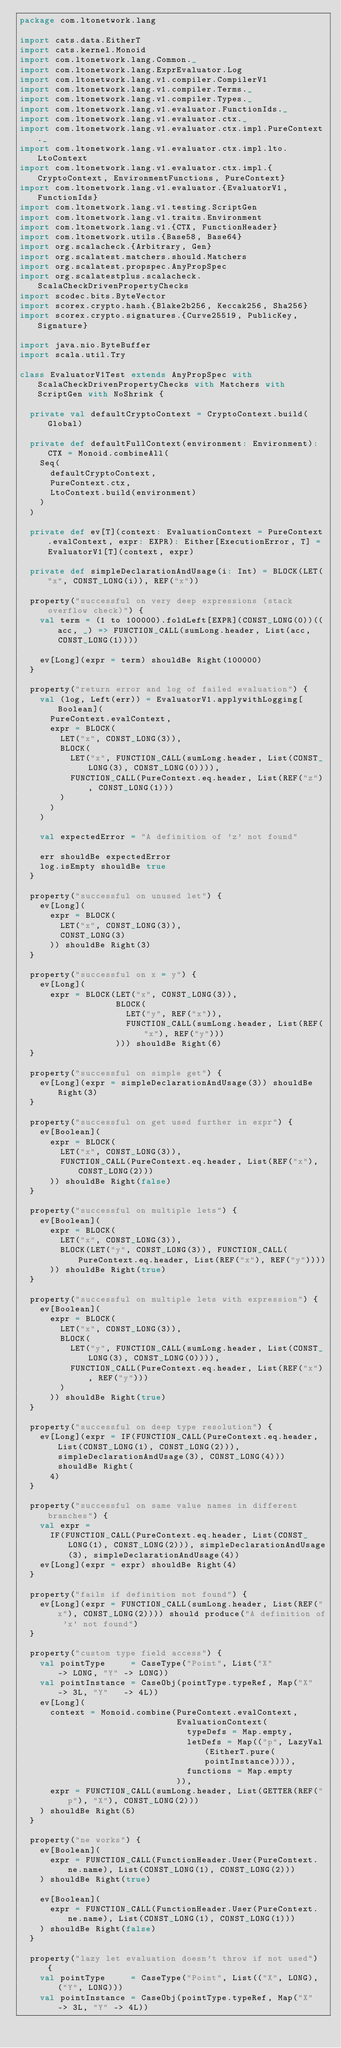<code> <loc_0><loc_0><loc_500><loc_500><_Scala_>package com.ltonetwork.lang

import cats.data.EitherT
import cats.kernel.Monoid
import com.ltonetwork.lang.Common._
import com.ltonetwork.lang.ExprEvaluator.Log
import com.ltonetwork.lang.v1.compiler.CompilerV1
import com.ltonetwork.lang.v1.compiler.Terms._
import com.ltonetwork.lang.v1.compiler.Types._
import com.ltonetwork.lang.v1.evaluator.FunctionIds._
import com.ltonetwork.lang.v1.evaluator.ctx._
import com.ltonetwork.lang.v1.evaluator.ctx.impl.PureContext._
import com.ltonetwork.lang.v1.evaluator.ctx.impl.lto.LtoContext
import com.ltonetwork.lang.v1.evaluator.ctx.impl.{CryptoContext, EnvironmentFunctions, PureContext}
import com.ltonetwork.lang.v1.evaluator.{EvaluatorV1, FunctionIds}
import com.ltonetwork.lang.v1.testing.ScriptGen
import com.ltonetwork.lang.v1.traits.Environment
import com.ltonetwork.lang.v1.{CTX, FunctionHeader}
import com.ltonetwork.utils.{Base58, Base64}
import org.scalacheck.{Arbitrary, Gen}
import org.scalatest.matchers.should.Matchers
import org.scalatest.propspec.AnyPropSpec
import org.scalatestplus.scalacheck.ScalaCheckDrivenPropertyChecks
import scodec.bits.ByteVector
import scorex.crypto.hash.{Blake2b256, Keccak256, Sha256}
import scorex.crypto.signatures.{Curve25519, PublicKey, Signature}

import java.nio.ByteBuffer
import scala.util.Try

class EvaluatorV1Test extends AnyPropSpec with ScalaCheckDrivenPropertyChecks with Matchers with ScriptGen with NoShrink {

  private val defaultCryptoContext = CryptoContext.build(Global)

  private def defaultFullContext(environment: Environment): CTX = Monoid.combineAll(
    Seq(
      defaultCryptoContext,
      PureContext.ctx,
      LtoContext.build(environment)
    )
  )

  private def ev[T](context: EvaluationContext = PureContext.evalContext, expr: EXPR): Either[ExecutionError, T] = EvaluatorV1[T](context, expr)

  private def simpleDeclarationAndUsage(i: Int) = BLOCK(LET("x", CONST_LONG(i)), REF("x"))

  property("successful on very deep expressions (stack overflow check)") {
    val term = (1 to 100000).foldLeft[EXPR](CONST_LONG(0))((acc, _) => FUNCTION_CALL(sumLong.header, List(acc, CONST_LONG(1))))

    ev[Long](expr = term) shouldBe Right(100000)
  }

  property("return error and log of failed evaluation") {
    val (log, Left(err)) = EvaluatorV1.applywithLogging[Boolean](
      PureContext.evalContext,
      expr = BLOCK(
        LET("x", CONST_LONG(3)),
        BLOCK(
          LET("x", FUNCTION_CALL(sumLong.header, List(CONST_LONG(3), CONST_LONG(0)))),
          FUNCTION_CALL(PureContext.eq.header, List(REF("z"), CONST_LONG(1)))
        )
      )
    )

    val expectedError = "A definition of 'z' not found"

    err shouldBe expectedError
    log.isEmpty shouldBe true
  }

  property("successful on unused let") {
    ev[Long](
      expr = BLOCK(
        LET("x", CONST_LONG(3)),
        CONST_LONG(3)
      )) shouldBe Right(3)
  }

  property("successful on x = y") {
    ev[Long](
      expr = BLOCK(LET("x", CONST_LONG(3)),
                   BLOCK(
                     LET("y", REF("x")),
                     FUNCTION_CALL(sumLong.header, List(REF("x"), REF("y")))
                   ))) shouldBe Right(6)
  }

  property("successful on simple get") {
    ev[Long](expr = simpleDeclarationAndUsage(3)) shouldBe Right(3)
  }

  property("successful on get used further in expr") {
    ev[Boolean](
      expr = BLOCK(
        LET("x", CONST_LONG(3)),
        FUNCTION_CALL(PureContext.eq.header, List(REF("x"), CONST_LONG(2)))
      )) shouldBe Right(false)
  }

  property("successful on multiple lets") {
    ev[Boolean](
      expr = BLOCK(
        LET("x", CONST_LONG(3)),
        BLOCK(LET("y", CONST_LONG(3)), FUNCTION_CALL(PureContext.eq.header, List(REF("x"), REF("y"))))
      )) shouldBe Right(true)
  }

  property("successful on multiple lets with expression") {
    ev[Boolean](
      expr = BLOCK(
        LET("x", CONST_LONG(3)),
        BLOCK(
          LET("y", FUNCTION_CALL(sumLong.header, List(CONST_LONG(3), CONST_LONG(0)))),
          FUNCTION_CALL(PureContext.eq.header, List(REF("x"), REF("y")))
        )
      )) shouldBe Right(true)
  }

  property("successful on deep type resolution") {
    ev[Long](expr = IF(FUNCTION_CALL(PureContext.eq.header, List(CONST_LONG(1), CONST_LONG(2))), simpleDeclarationAndUsage(3), CONST_LONG(4))) shouldBe Right(
      4)
  }

  property("successful on same value names in different branches") {
    val expr =
      IF(FUNCTION_CALL(PureContext.eq.header, List(CONST_LONG(1), CONST_LONG(2))), simpleDeclarationAndUsage(3), simpleDeclarationAndUsage(4))
    ev[Long](expr = expr) shouldBe Right(4)
  }

  property("fails if definition not found") {
    ev[Long](expr = FUNCTION_CALL(sumLong.header, List(REF("x"), CONST_LONG(2)))) should produce("A definition of 'x' not found")
  }

  property("custom type field access") {
    val pointType     = CaseType("Point", List("X"         -> LONG, "Y" -> LONG))
    val pointInstance = CaseObj(pointType.typeRef, Map("X" -> 3L, "Y"   -> 4L))
    ev[Long](
      context = Monoid.combine(PureContext.evalContext,
                               EvaluationContext(
                                 typeDefs = Map.empty,
                                 letDefs = Map(("p", LazyVal(EitherT.pure(pointInstance)))),
                                 functions = Map.empty
                               )),
      expr = FUNCTION_CALL(sumLong.header, List(GETTER(REF("p"), "X"), CONST_LONG(2)))
    ) shouldBe Right(5)
  }

  property("ne works") {
    ev[Boolean](
      expr = FUNCTION_CALL(FunctionHeader.User(PureContext.ne.name), List(CONST_LONG(1), CONST_LONG(2)))
    ) shouldBe Right(true)

    ev[Boolean](
      expr = FUNCTION_CALL(FunctionHeader.User(PureContext.ne.name), List(CONST_LONG(1), CONST_LONG(1)))
    ) shouldBe Right(false)
  }

  property("lazy let evaluation doesn't throw if not used") {
    val pointType     = CaseType("Point", List(("X", LONG), ("Y", LONG)))
    val pointInstance = CaseObj(pointType.typeRef, Map("X" -> 3L, "Y" -> 4L))</code> 